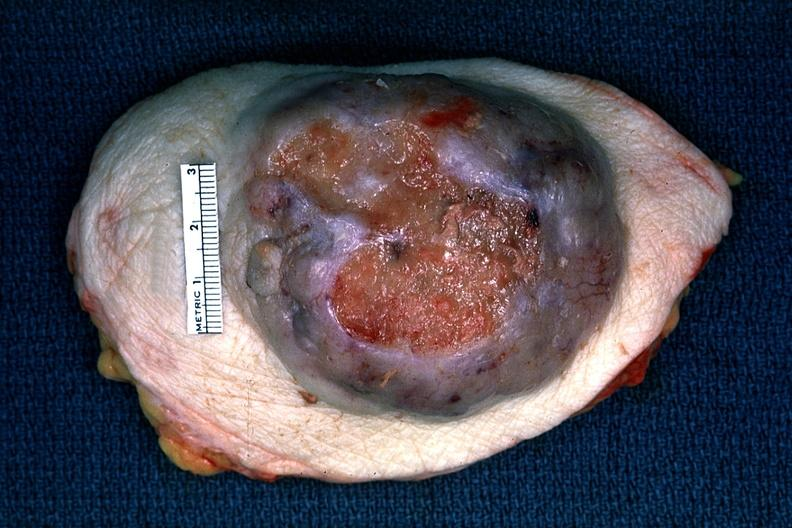what is present?
Answer the question using a single word or phrase. Breast 